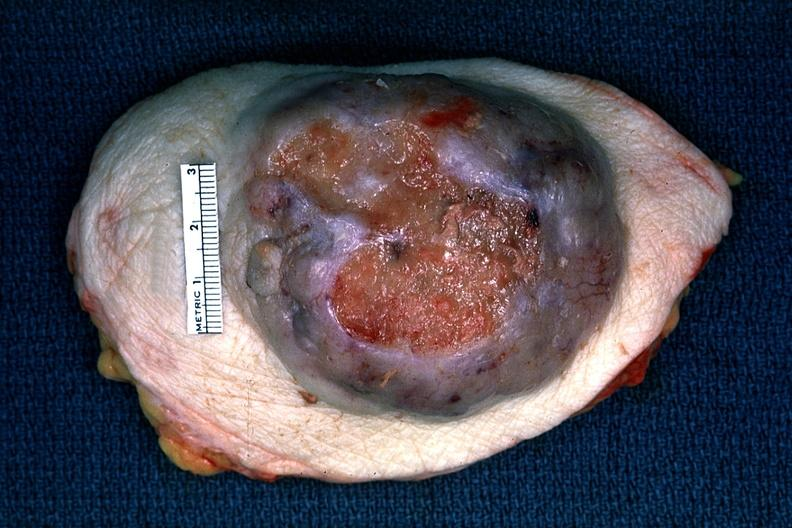what is present?
Answer the question using a single word or phrase. Breast 